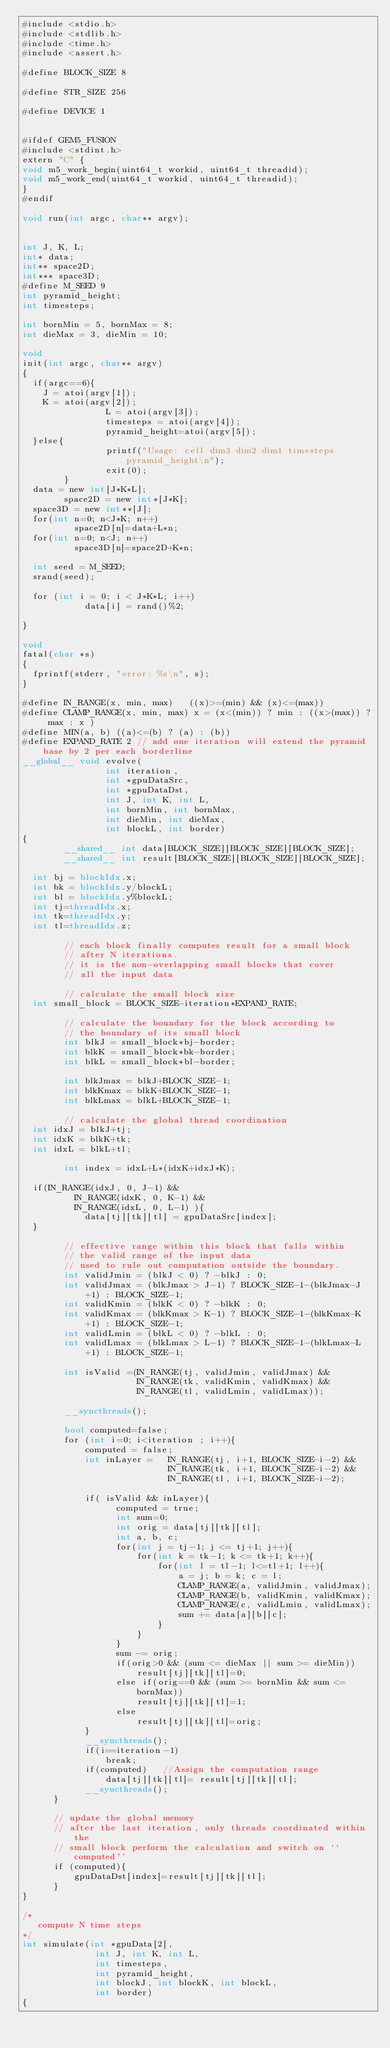<code> <loc_0><loc_0><loc_500><loc_500><_Cuda_>#include <stdio.h>
#include <stdlib.h>
#include <time.h>
#include <assert.h>

#define BLOCK_SIZE 8

#define STR_SIZE 256

#define DEVICE 1


#ifdef GEM5_FUSION
#include <stdint.h>
extern "C" {
void m5_work_begin(uint64_t workid, uint64_t threadid);
void m5_work_end(uint64_t workid, uint64_t threadid);
}
#endif

void run(int argc, char** argv);


int J, K, L;
int* data;
int** space2D;
int*** space3D;
#define M_SEED 9
int pyramid_height;
int timesteps;

int bornMin = 5, bornMax = 8;
int dieMax = 3, dieMin = 10;

void
init(int argc, char** argv)
{
	if(argc==6){
		J = atoi(argv[1]);
		K = atoi(argv[2]);
                L = atoi(argv[3]);
                timesteps = atoi(argv[4]);
                pyramid_height=atoi(argv[5]);
	}else{
                printf("Usage: cell dim3 dim2 dim1 timesteps pyramid_height\n");
                exit(0);
        }
	data = new int[J*K*L];
        space2D = new int*[J*K];
	space3D = new int**[J];
	for(int n=0; n<J*K; n++)
          space2D[n]=data+L*n;
	for(int n=0; n<J; n++)
          space3D[n]=space2D+K*n;

	int seed = M_SEED;
	srand(seed);

	for (int i = 0; i < J*K*L; i++)
            data[i] = rand()%2;

}

void
fatal(char *s)
{
	fprintf(stderr, "error: %s\n", s);
}

#define IN_RANGE(x, min, max)   ((x)>=(min) && (x)<=(max))
#define CLAMP_RANGE(x, min, max) x = (x<(min)) ? min : ((x>(max)) ? max : x )
#define MIN(a, b) ((a)<=(b) ? (a) : (b))
#define EXPAND_RATE 2 // add one iteration will extend the pyramid base by 2 per each borderline
__global__ void evolve(
                int iteration,
                int *gpuDataSrc,
                int *gpuDataDst,
                int J, int K, int L,
                int bornMin, int bornMax,
                int dieMin, int dieMax,
                int blockL, int border)
{
        __shared__ int data[BLOCK_SIZE][BLOCK_SIZE][BLOCK_SIZE];
        __shared__ int result[BLOCK_SIZE][BLOCK_SIZE][BLOCK_SIZE];

	int bj = blockIdx.x;
	int bk = blockIdx.y/blockL;
	int bl = blockIdx.y%blockL;
	int tj=threadIdx.x;
	int tk=threadIdx.y;
	int tl=threadIdx.z;

        // each block finally computes result for a small block
        // after N iterations.
        // it is the non-overlapping small blocks that cover
        // all the input data

        // calculate the small block size
	int small_block = BLOCK_SIZE-iteration*EXPAND_RATE;

        // calculate the boundary for the block according to
        // the boundary of its small block
        int blkJ = small_block*bj-border;
        int blkK = small_block*bk-border;
        int blkL = small_block*bl-border;

        int blkJmax = blkJ+BLOCK_SIZE-1;
        int blkKmax = blkK+BLOCK_SIZE-1;
        int blkLmax = blkL+BLOCK_SIZE-1;

        // calculate the global thread coordination
	int idxJ = blkJ+tj;
	int idxK = blkK+tk;
	int idxL = blkL+tl;

        int index = idxL+L*(idxK+idxJ*K);

	if(IN_RANGE(idxJ, 0, J-1) &&
          IN_RANGE(idxK, 0, K-1) &&
          IN_RANGE(idxL, 0, L-1) ){
            data[tj][tk][tl] = gpuDataSrc[index];
	}

        // effective range within this block that falls within
        // the valid range of the input data
        // used to rule out computation outside the boundary.
        int validJmin = (blkJ < 0) ? -blkJ : 0;
        int validJmax = (blkJmax > J-1) ? BLOCK_SIZE-1-(blkJmax-J+1) : BLOCK_SIZE-1;
        int validKmin = (blkK < 0) ? -blkK : 0;
        int validKmax = (blkKmax > K-1) ? BLOCK_SIZE-1-(blkKmax-K+1) : BLOCK_SIZE-1;
        int validLmin = (blkL < 0) ? -blkL : 0;
        int validLmax = (blkLmax > L-1) ? BLOCK_SIZE-1-(blkLmax-L+1) : BLOCK_SIZE-1;

        int isValid =(IN_RANGE(tj, validJmin, validJmax) &&
                      IN_RANGE(tk, validKmin, validKmax) &&
                      IN_RANGE(tl, validLmin, validLmax));

        __syncthreads();

        bool computed=false;
        for (int i=0; i<iteration ; i++){
            computed = false;
            int inLayer =   IN_RANGE(tj, i+1, BLOCK_SIZE-i-2) &&
                            IN_RANGE(tk, i+1, BLOCK_SIZE-i-2) &&
                            IN_RANGE(tl, i+1, BLOCK_SIZE-i-2);

            if( isValid && inLayer){
                  computed = true;
                  int sum=0;
                  int orig = data[tj][tk][tl];
                  int a, b, c;
                  for(int j = tj-1; j <= tj+1; j++){
                      for(int k = tk-1; k <= tk+1; k++){
                          for(int l = tl-1; l<=tl+1; l++){
                              a = j; b = k; c = l;
                              CLAMP_RANGE(a, validJmin, validJmax);
                              CLAMP_RANGE(b, validKmin, validKmax);
                              CLAMP_RANGE(c, validLmin, validLmax);
                              sum += data[a][b][c];
                          }
                      }
                  }
                  sum -= orig;
                  if(orig>0 && (sum <= dieMax || sum >= dieMin))
                      result[tj][tk][tl]=0;
                  else if(orig==0 && (sum >= bornMin && sum <= bornMax))
                      result[tj][tk][tl]=1;
                  else
                      result[tj][tk][tl]=orig;
            }
            __syncthreads();
            if(i==iteration-1)
                break;
            if(computed)	 //Assign the computation range
                data[tj][tk][tl]= result[tj][tk][tl];
            __syncthreads();
      }

      // update the global memory
      // after the last iteration, only threads coordinated within the
      // small block perform the calculation and switch on ``computed''
      if (computed){
          gpuDataDst[index]=result[tj][tk][tl];
      }
}

/*
   compute N time steps
*/
int simulate(int *gpuData[2],
              int J, int K, int L,
              int timesteps,
              int pyramid_height,
              int blockJ, int blockK, int blockL,
              int border)
{</code> 